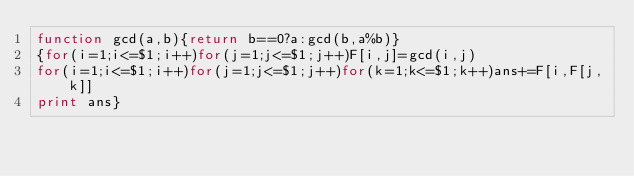Convert code to text. <code><loc_0><loc_0><loc_500><loc_500><_Awk_>function gcd(a,b){return b==0?a:gcd(b,a%b)}
{for(i=1;i<=$1;i++)for(j=1;j<=$1;j++)F[i,j]=gcd(i,j)
for(i=1;i<=$1;i++)for(j=1;j<=$1;j++)for(k=1;k<=$1;k++)ans+=F[i,F[j,k]]
print ans}</code> 